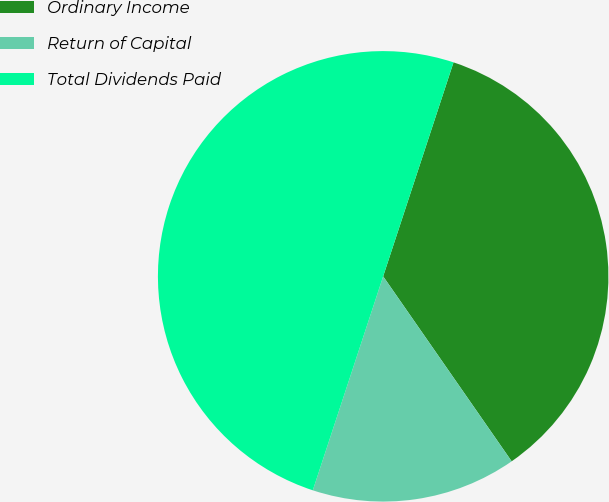Convert chart. <chart><loc_0><loc_0><loc_500><loc_500><pie_chart><fcel>Ordinary Income<fcel>Return of Capital<fcel>Total Dividends Paid<nl><fcel>35.28%<fcel>14.72%<fcel>50.0%<nl></chart> 